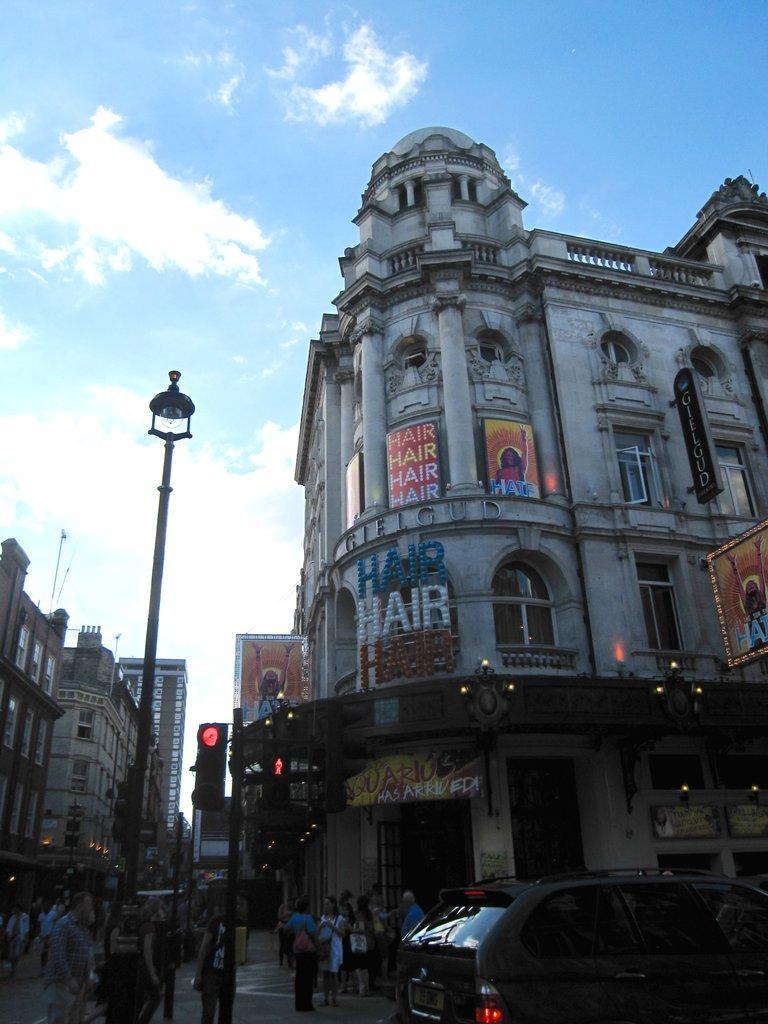Could you give a brief overview of what you see in this image? To the bottom of the image there is a pole with traffic signals and also there are few people standing. And to the right bottom corner of the image there is a black car. And in the background to the right side of the image there is a building with windows, pillars, name boards and walls. And to the left corner of the image there are buildings. And to the top of the image there is a sky. 